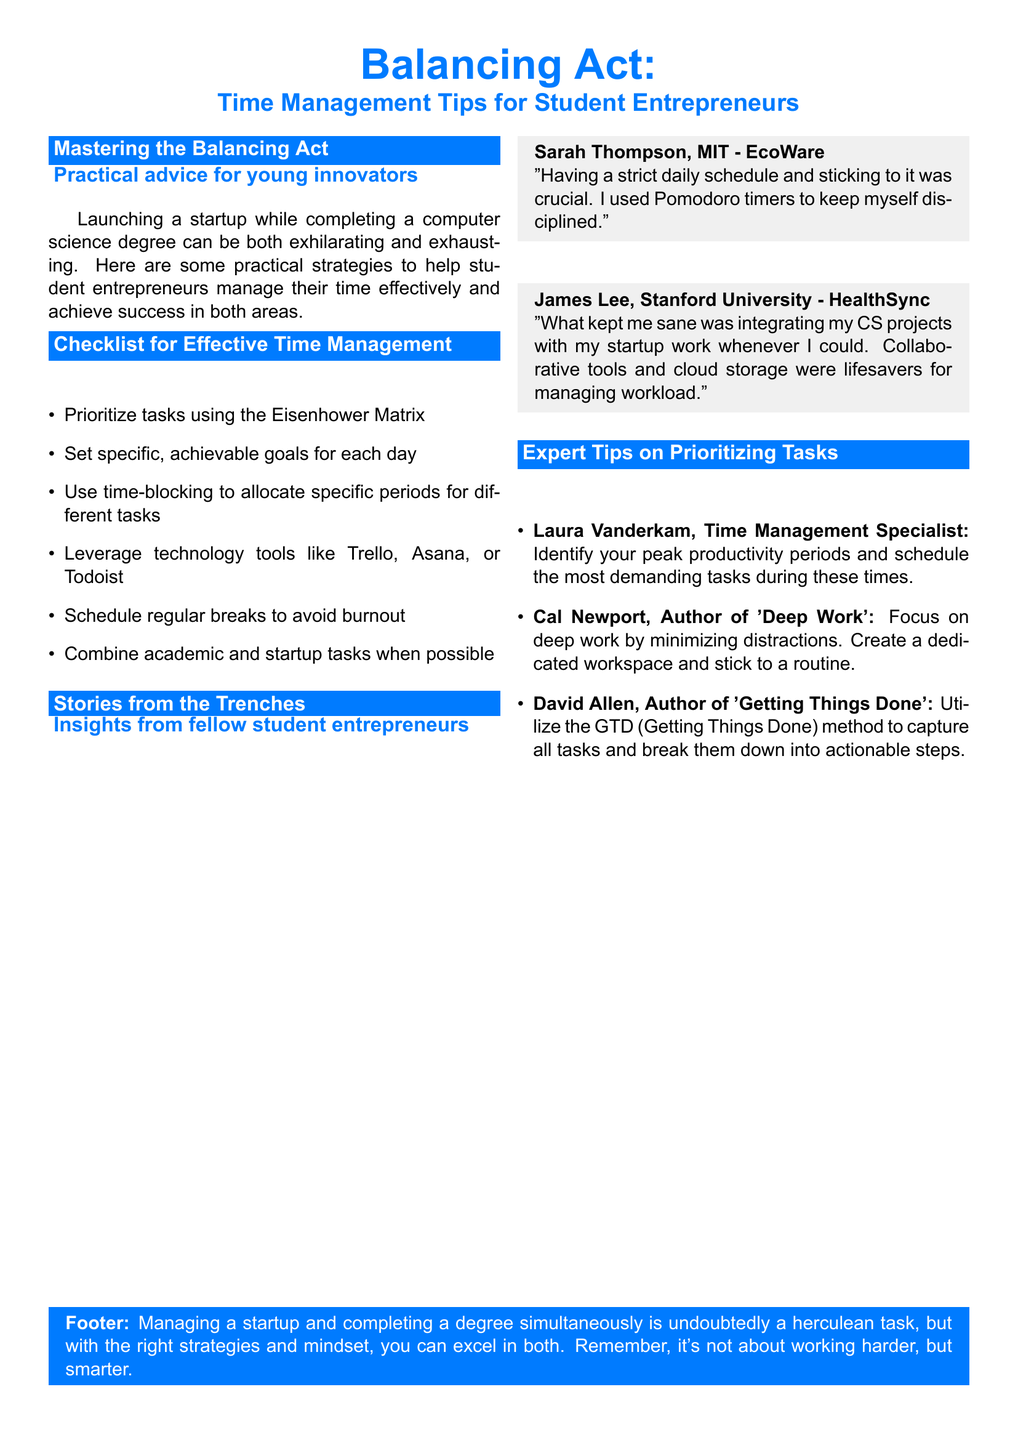What is the title of the document? The title is mentioned prominently at the top of the document as "Balancing Act: Time Management Tips for Student Entrepreneurs."
Answer: Balancing Act: Time Management Tips for Student Entrepreneurs Who provided a tip about identifying peak productivity periods? The document names Laura Vanderkam as the Time Management Specialist who offers this tip.
Answer: Laura Vanderkam What is one tool suggested for task management? The checklist provides several tools, one of which is Trello as mentioned under technology tools.
Answer: Trello Which university does Sarah Thompson attend? The document states Sarah Thompson is from MIT in the section with personal stories.
Answer: MIT How many points are listed in the checklist for effective time management? The checklist contains six specific points regarding time management strategies.
Answer: Six What productivity technique did Sarah Thompson mention using? The personal story section includes Sarah mentioning the use of Pomodoro timers.
Answer: Pomodoro timers What method does David Allen advocate for task management? David Allen's method is referred to as Getting Things Done in the expert tips section.
Answer: Getting Things Done What is the core recommendation for managing tasks according to the document? The footer highlights the idea that it's important to work smarter, not harder.
Answer: Work smarter, not harder 